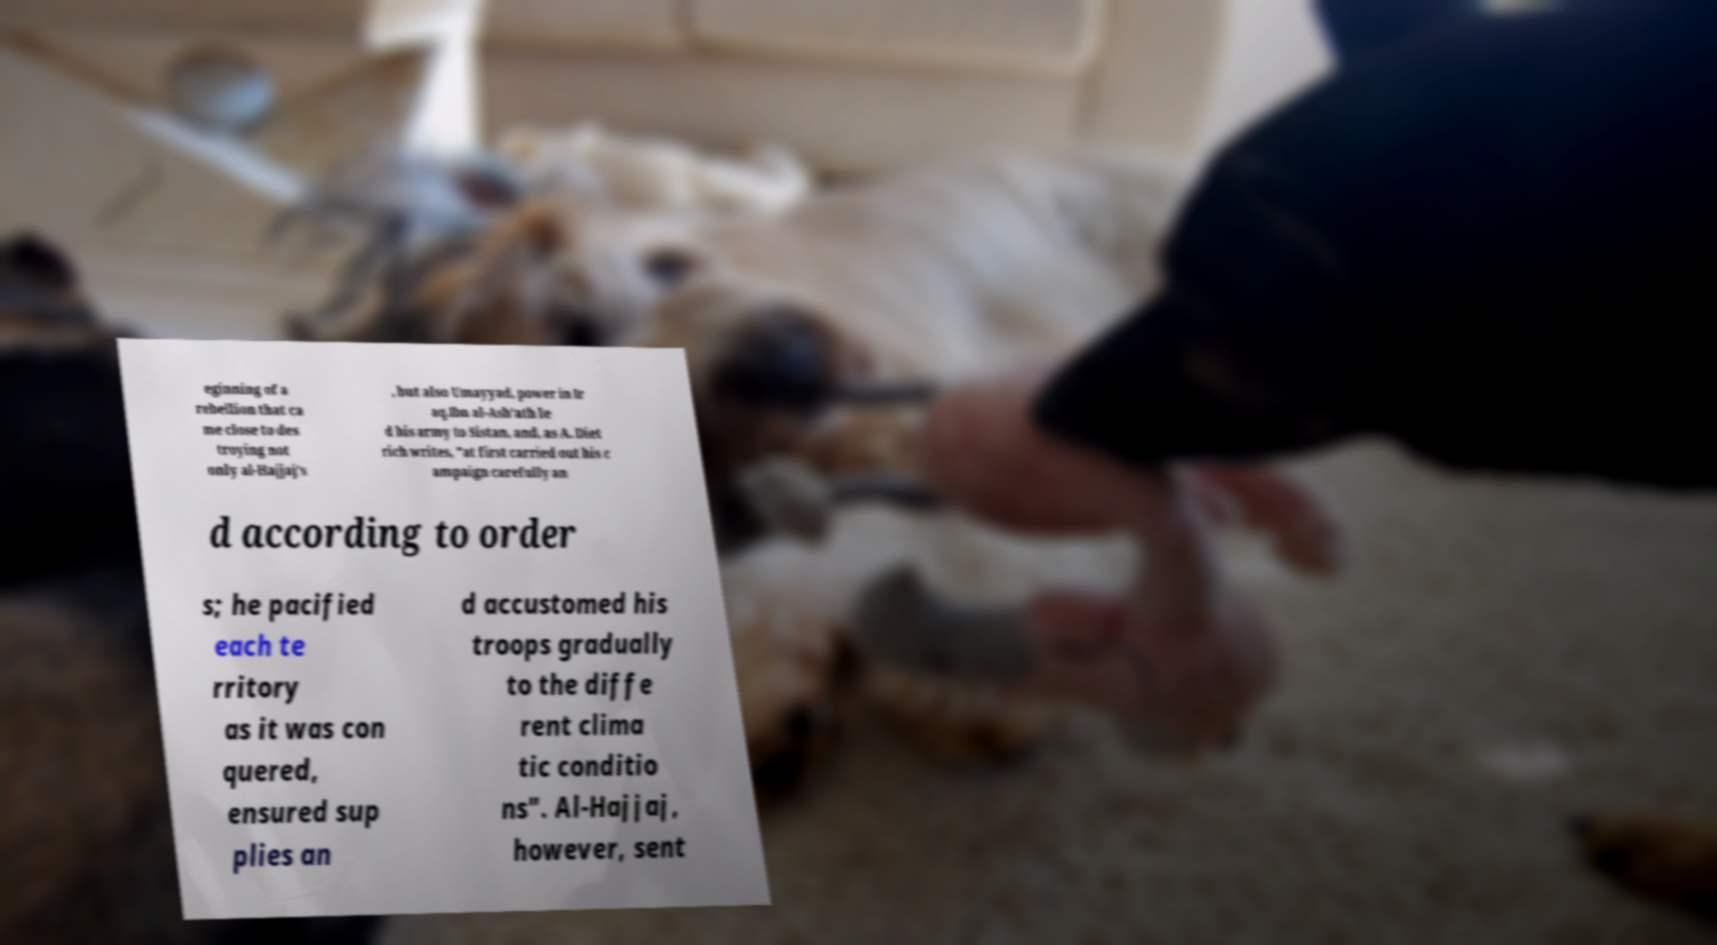Please read and relay the text visible in this image. What does it say? eginning of a rebellion that ca me close to des troying not only al-Hajjaj's , but also Umayyad, power in Ir aq.Ibn al-Ash'ath le d his army to Sistan, and, as A. Diet rich writes, "at first carried out his c ampaign carefully an d according to order s; he pacified each te rritory as it was con quered, ensured sup plies an d accustomed his troops gradually to the diffe rent clima tic conditio ns". Al-Hajjaj, however, sent 